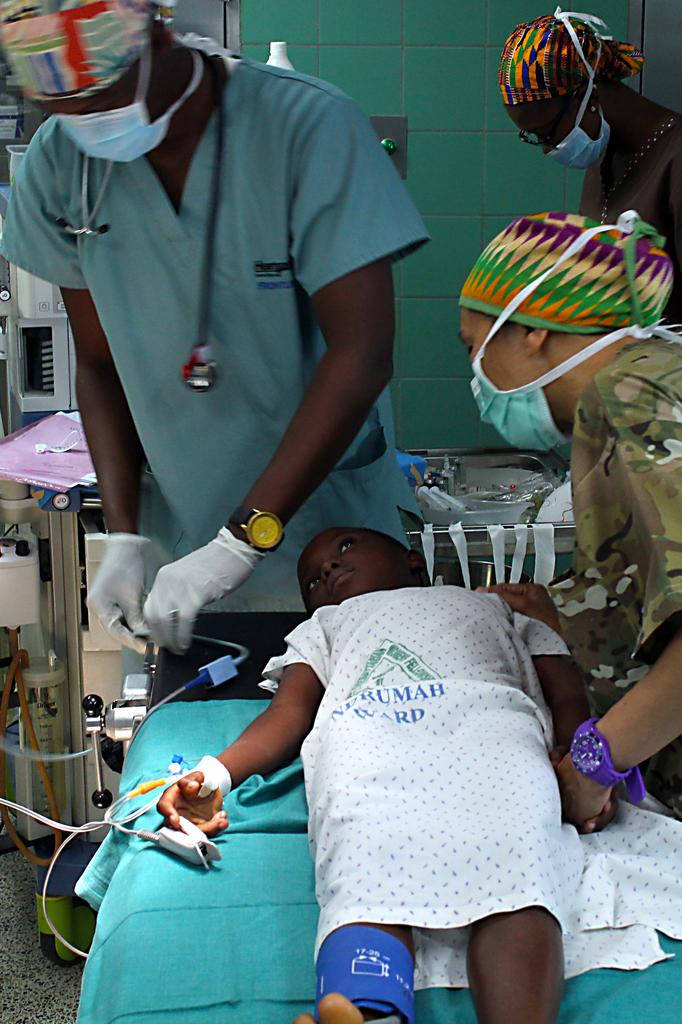How many people are wearing face masks in the image? There are three people wearing face masks in the image. What is the child doing in the image? The child is lying on a bed in the image. What can be seen in the background of the image? There is a wall, a tray, and some objects visible in the background of the image. What is the reason for the child's self-reflection in the image? There is no indication of self-reflection or a reason for it in the image. 